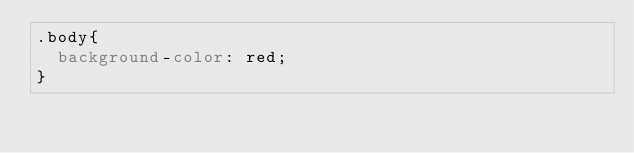Convert code to text. <code><loc_0><loc_0><loc_500><loc_500><_CSS_>.body{
	background-color: red;
}</code> 